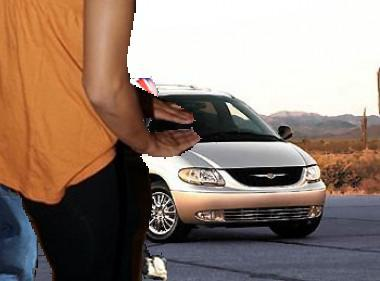Describe what the person in the image is doing. The person in the image appears to be standing beside the car, possibly interacting with something in their hands, though specific activity isn't clear due to the limited view. 